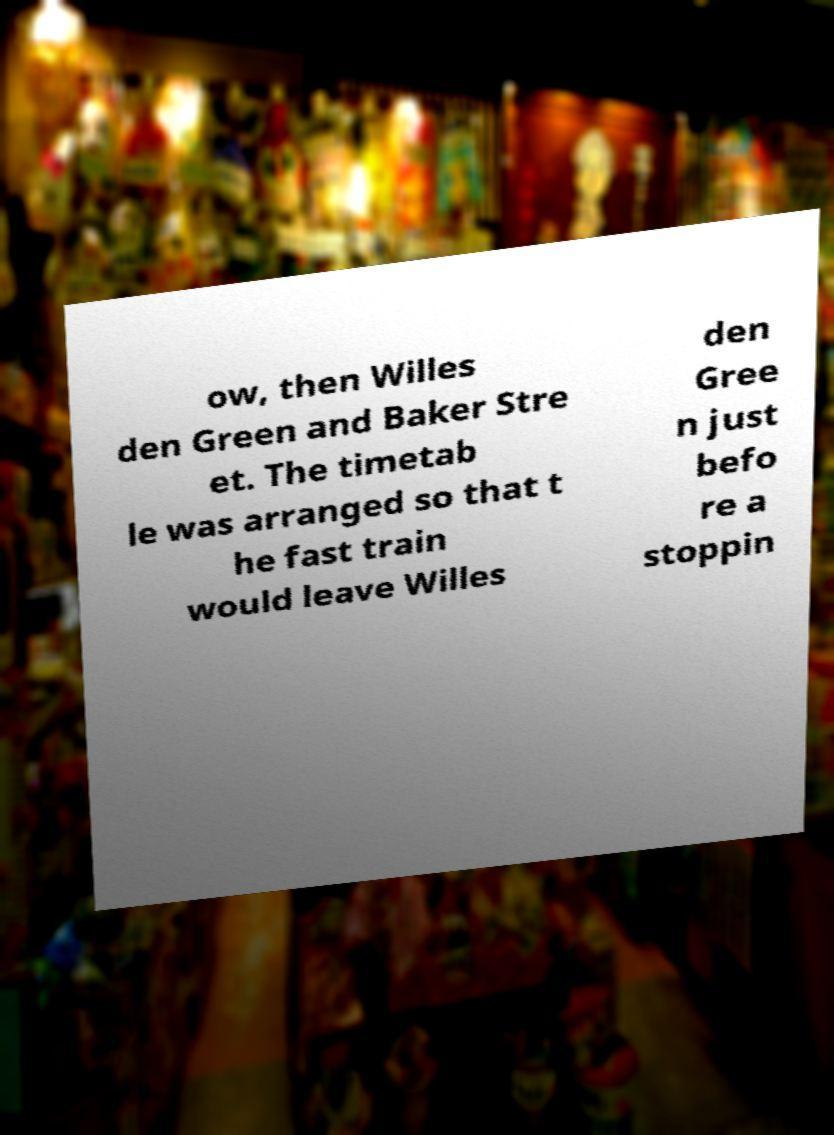Could you assist in decoding the text presented in this image and type it out clearly? ow, then Willes den Green and Baker Stre et. The timetab le was arranged so that t he fast train would leave Willes den Gree n just befo re a stoppin 